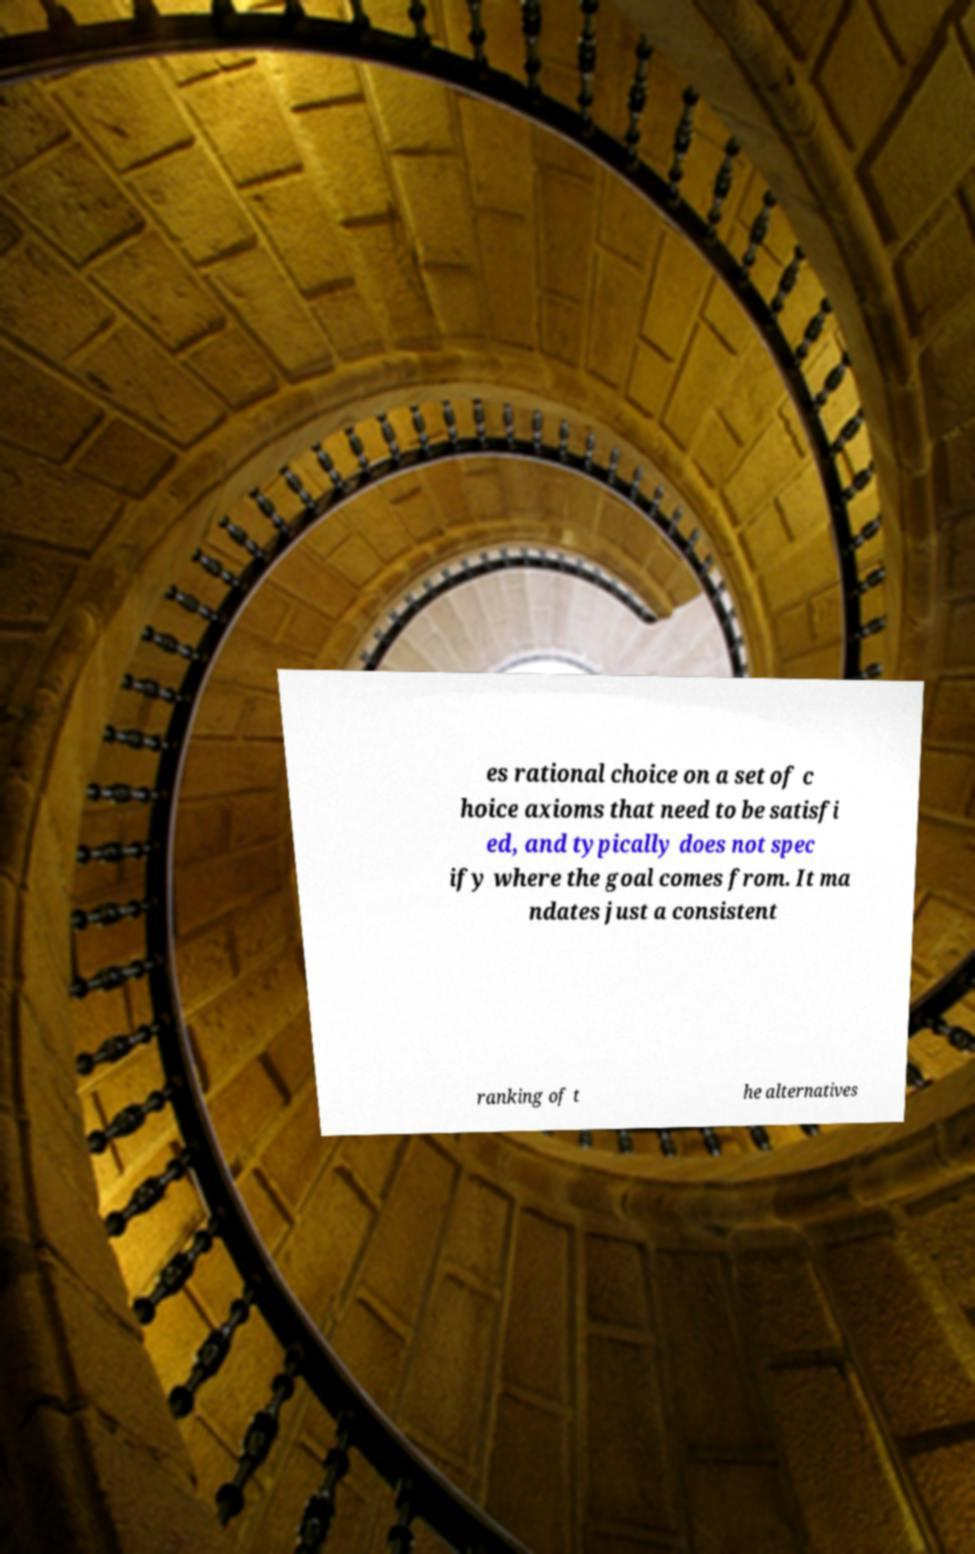For documentation purposes, I need the text within this image transcribed. Could you provide that? es rational choice on a set of c hoice axioms that need to be satisfi ed, and typically does not spec ify where the goal comes from. It ma ndates just a consistent ranking of t he alternatives 